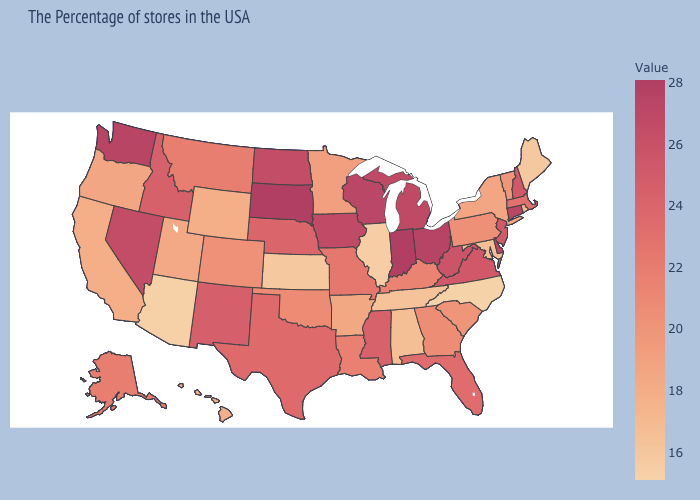Among the states that border Massachusetts , does Vermont have the highest value?
Keep it brief. No. Does North Carolina have a lower value than Connecticut?
Answer briefly. Yes. Does the map have missing data?
Keep it brief. No. Which states have the highest value in the USA?
Write a very short answer. Indiana, South Dakota. Does Kansas have a lower value than Wyoming?
Short answer required. Yes. Does Mississippi have a higher value than Alaska?
Concise answer only. Yes. Which states hav the highest value in the MidWest?
Write a very short answer. Indiana, South Dakota. 